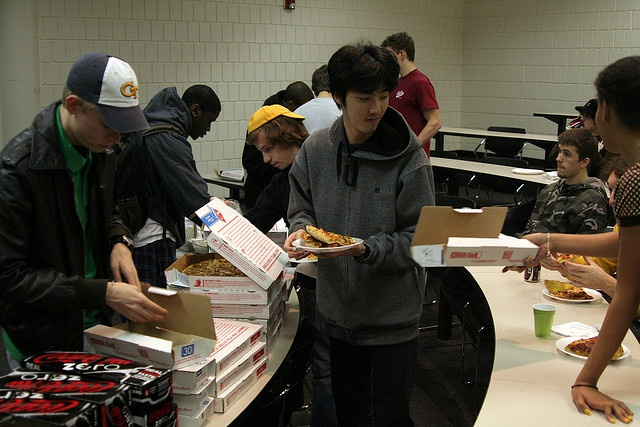Describe the objects in this image and their specific colors. I can see people in darkgreen, black, gray, and maroon tones, people in darkgreen, black, maroon, gray, and tan tones, people in darkgreen, black, gray, darkgray, and purple tones, people in darkgreen, black, maroon, and brown tones, and people in darkgreen, black, maroon, and gray tones in this image. 